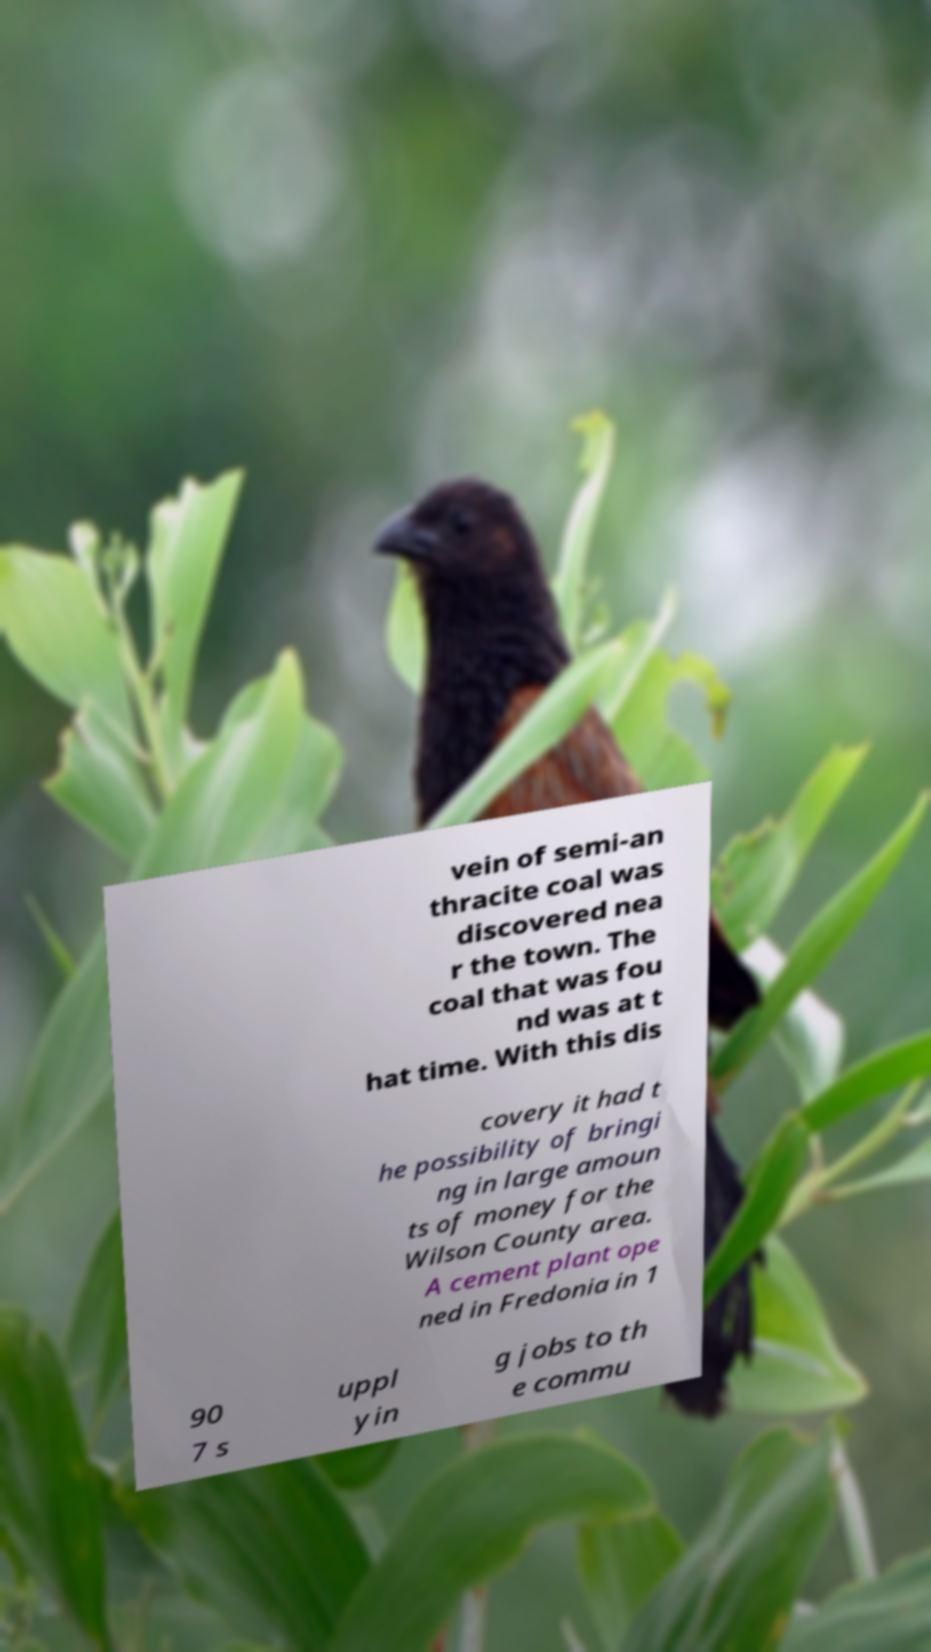Could you extract and type out the text from this image? vein of semi-an thracite coal was discovered nea r the town. The coal that was fou nd was at t hat time. With this dis covery it had t he possibility of bringi ng in large amoun ts of money for the Wilson County area. A cement plant ope ned in Fredonia in 1 90 7 s uppl yin g jobs to th e commu 